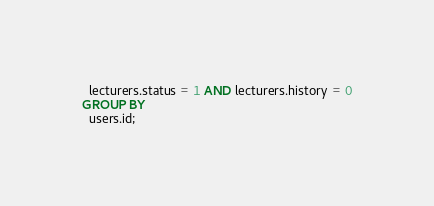<code> <loc_0><loc_0><loc_500><loc_500><_SQL_>  lecturers.status = 1 AND lecturers.history = 0
GROUP BY
  users.id;</code> 